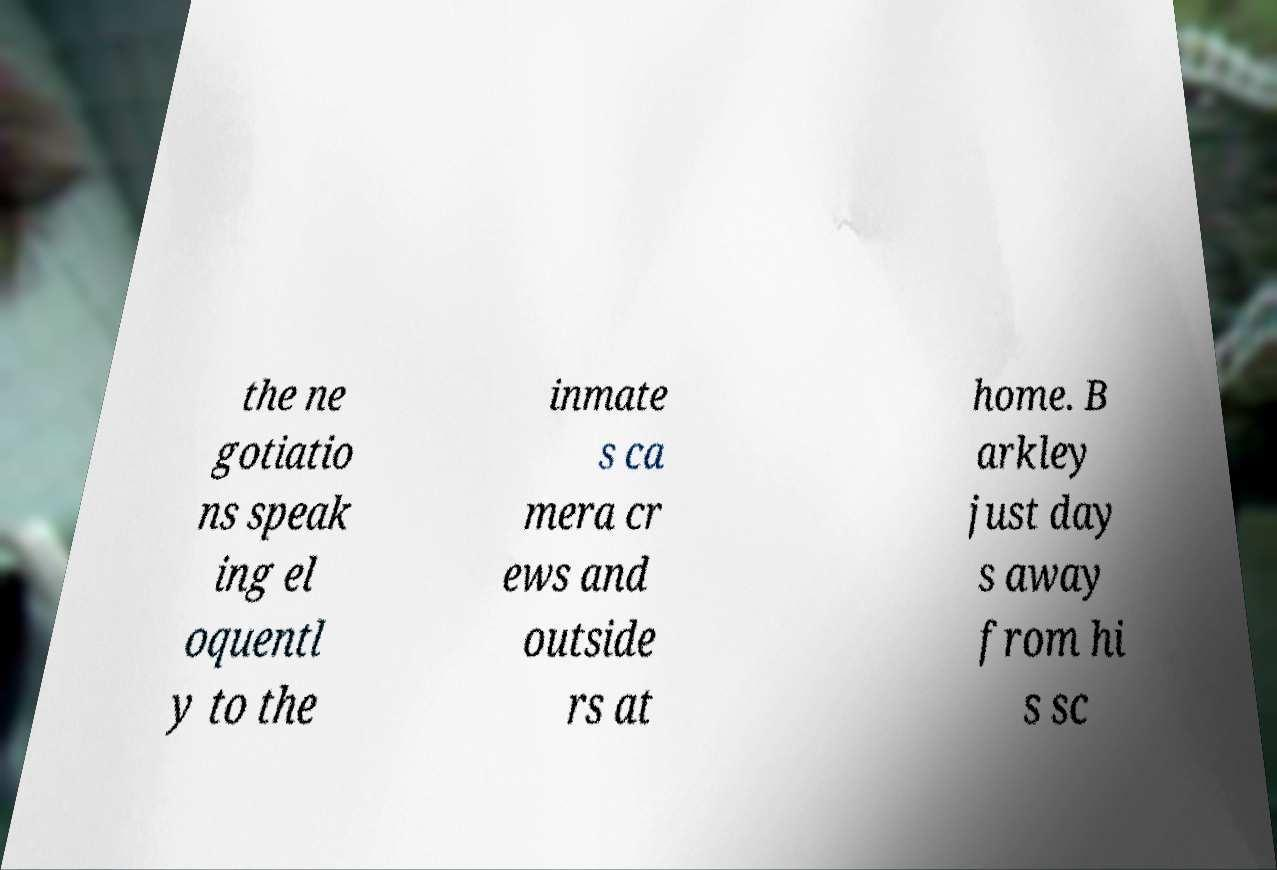There's text embedded in this image that I need extracted. Can you transcribe it verbatim? the ne gotiatio ns speak ing el oquentl y to the inmate s ca mera cr ews and outside rs at home. B arkley just day s away from hi s sc 